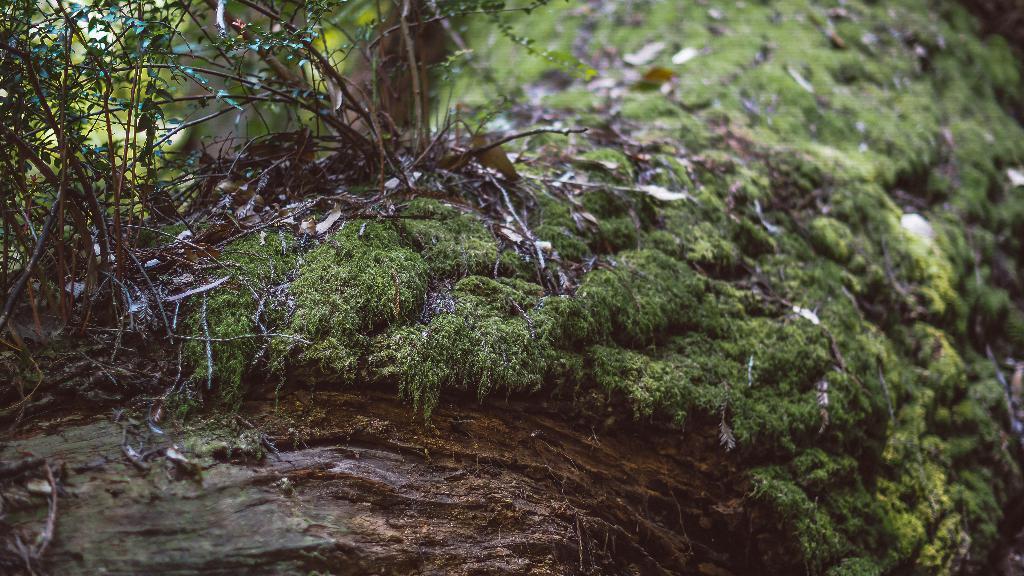In one or two sentences, can you explain what this image depicts? In this image I can see a tree trunk and on it I can see some grass, few leaves and a plant. I can see the blurry background which is green in color. 